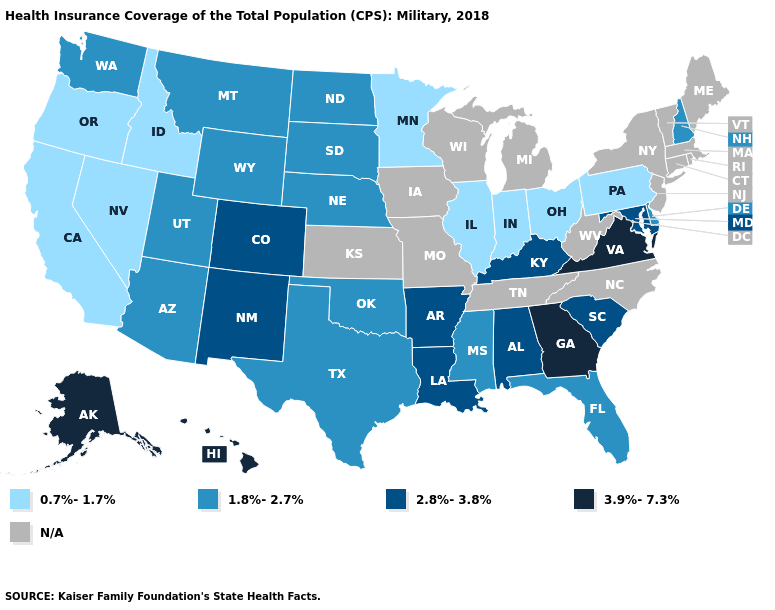What is the value of Maine?
Answer briefly. N/A. Among the states that border Oklahoma , does New Mexico have the lowest value?
Concise answer only. No. Does the first symbol in the legend represent the smallest category?
Quick response, please. Yes. What is the value of Idaho?
Keep it brief. 0.7%-1.7%. What is the value of Texas?
Be succinct. 1.8%-2.7%. Does Ohio have the highest value in the MidWest?
Quick response, please. No. Does Oregon have the lowest value in the USA?
Short answer required. Yes. What is the value of South Carolina?
Give a very brief answer. 2.8%-3.8%. Among the states that border South Dakota , does Nebraska have the highest value?
Short answer required. Yes. What is the value of Mississippi?
Quick response, please. 1.8%-2.7%. Name the states that have a value in the range 1.8%-2.7%?
Short answer required. Arizona, Delaware, Florida, Mississippi, Montana, Nebraska, New Hampshire, North Dakota, Oklahoma, South Dakota, Texas, Utah, Washington, Wyoming. What is the value of Vermont?
Be succinct. N/A. Does the map have missing data?
Write a very short answer. Yes. 